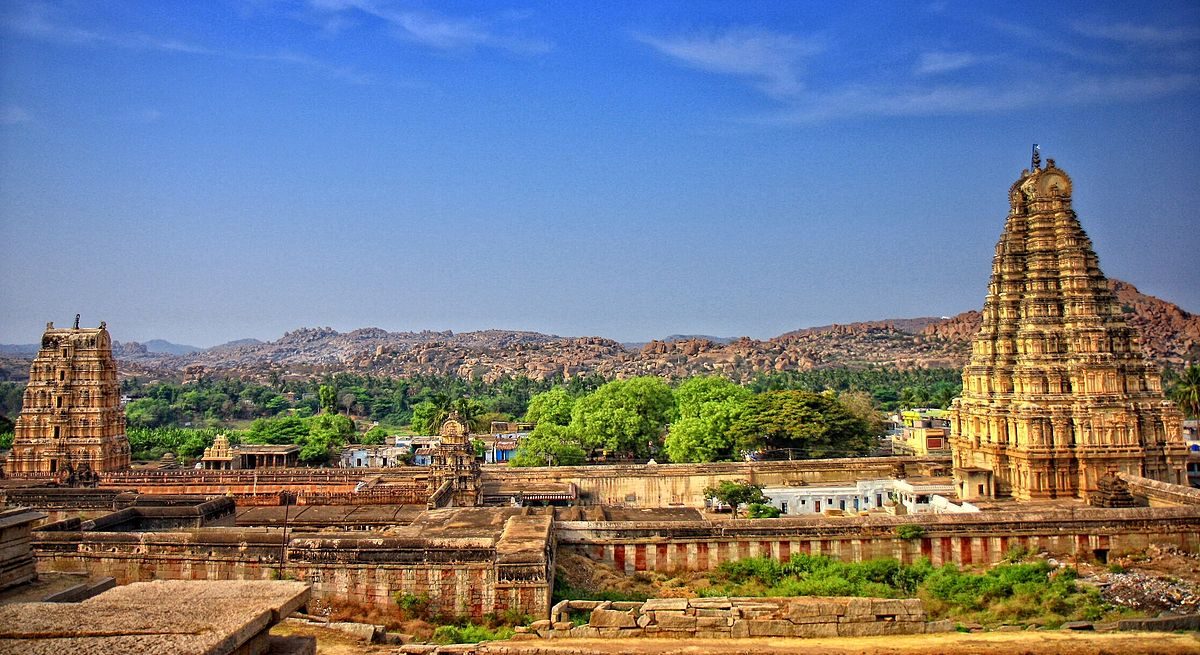What historical events have shaped the Virupaksha Temple? The Virupaksha Temple has been an active site of worship since approximately the 7th century AD. Its history is profoundly intertwined with the rise and fall of the Vijayanagara Empire in the 14th to 17th centuries. The temple flourished under the patronage of the Vijayanagara rulers, who expanded and embellished it. Many of these enhancements are visible in the elaborate architectural designs and inscriptions found on its walls. After the fall of the empire post the Battle of Talikota in 1565, the temple faced neglect but continued its religious significance and has since been preserved and celebrated as a key symbol of the Indo-Hindu culture and history. 